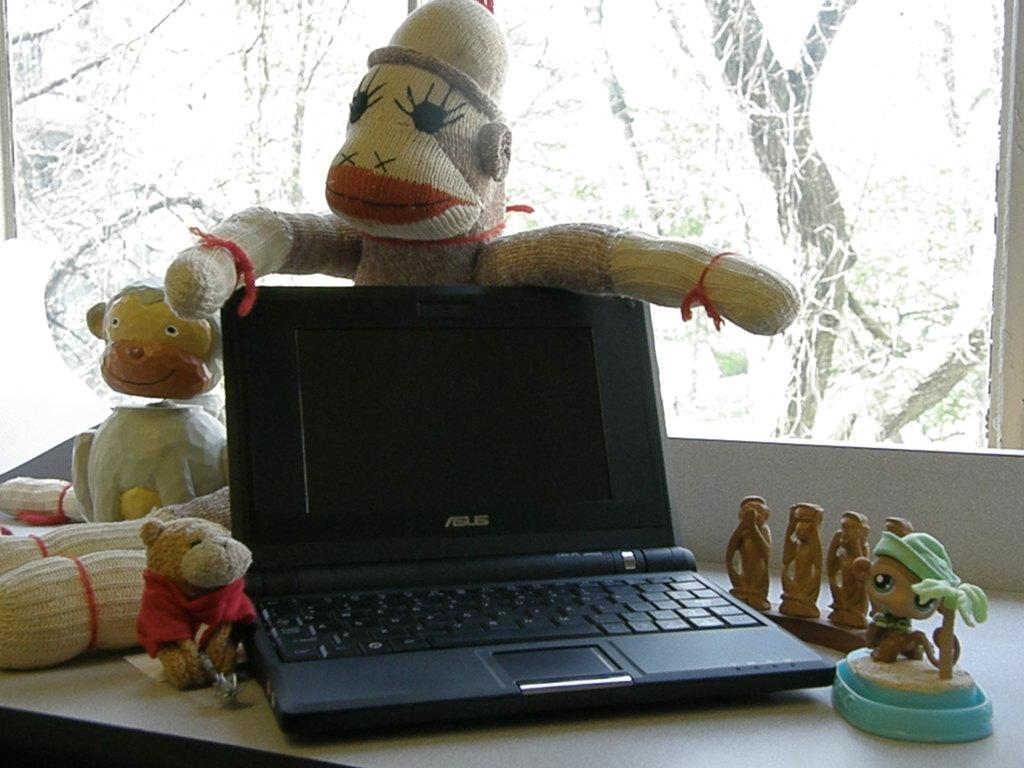What is the main piece of furniture in the image? There is a table in the image. What is placed on the table? There are dolls and a black laptop on the table. What can be seen through the window in the image? Trees and plants are visible through the window. Where is the rifle placed in the image? There is no rifle present in the image. 